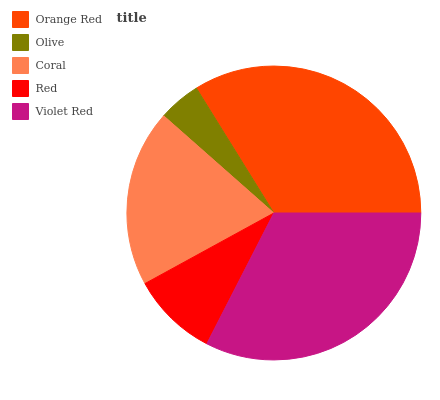Is Olive the minimum?
Answer yes or no. Yes. Is Orange Red the maximum?
Answer yes or no. Yes. Is Coral the minimum?
Answer yes or no. No. Is Coral the maximum?
Answer yes or no. No. Is Coral greater than Olive?
Answer yes or no. Yes. Is Olive less than Coral?
Answer yes or no. Yes. Is Olive greater than Coral?
Answer yes or no. No. Is Coral less than Olive?
Answer yes or no. No. Is Coral the high median?
Answer yes or no. Yes. Is Coral the low median?
Answer yes or no. Yes. Is Orange Red the high median?
Answer yes or no. No. Is Red the low median?
Answer yes or no. No. 